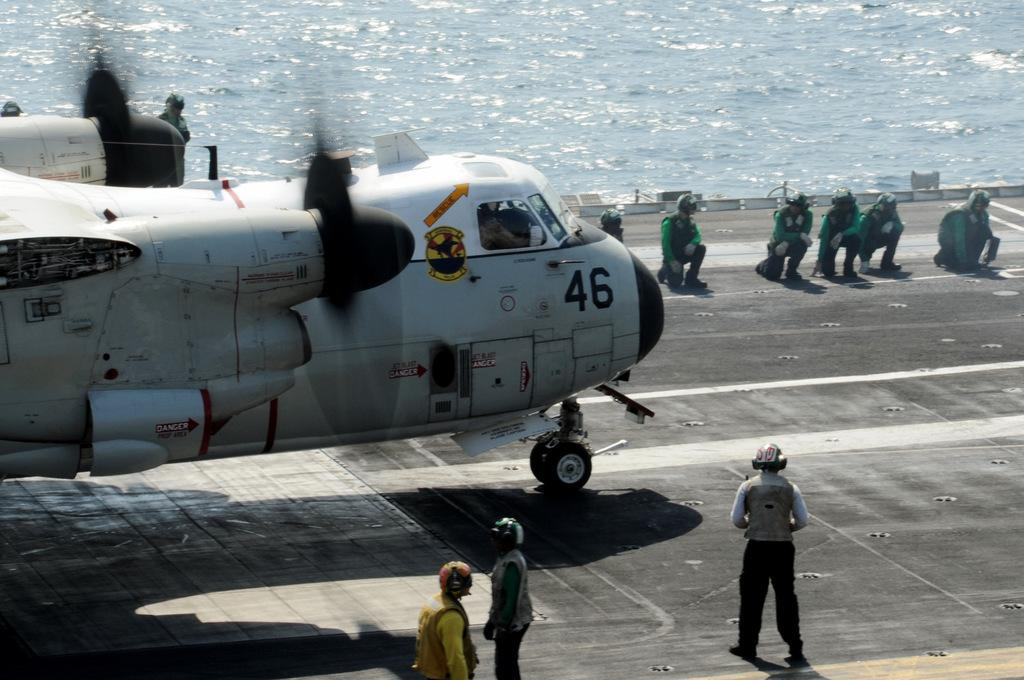What is the main subject of the image? The main subject of the image is an aeroplane. What are the people in the image doing? The people in the image are standing and observing the aeroplane. What natural element is visible in the image? There is water visible in the image. What month is depicted in the image? The image does not depict a specific month; it features an aeroplane and people observing it. What historical event is taking place in the image? The image does not depict a historical event; it simply shows an aeroplane and people observing it. 